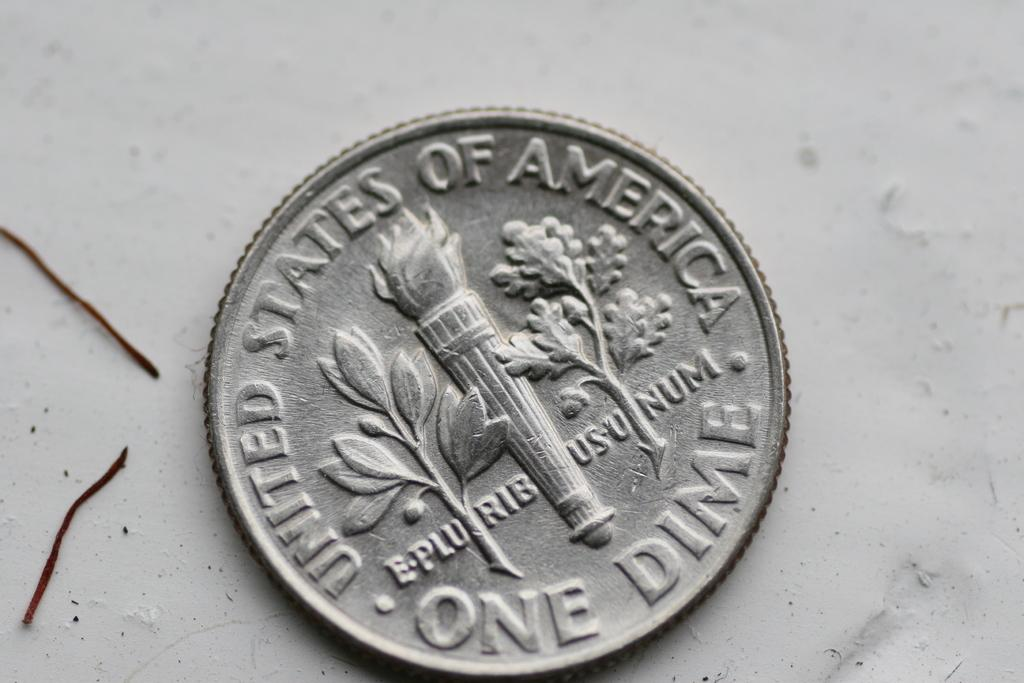What object is the main subject of the image? There is a coin in the image. What is the color of the coin? The coin is silver in color. What is the background of the image? The coin is on a white colored surface. What can be seen on the coin? There is something printed on the coin. How many toes can be seen on the coin in the image? There are no toes visible on the coin in the image, as coins do not have toes. 